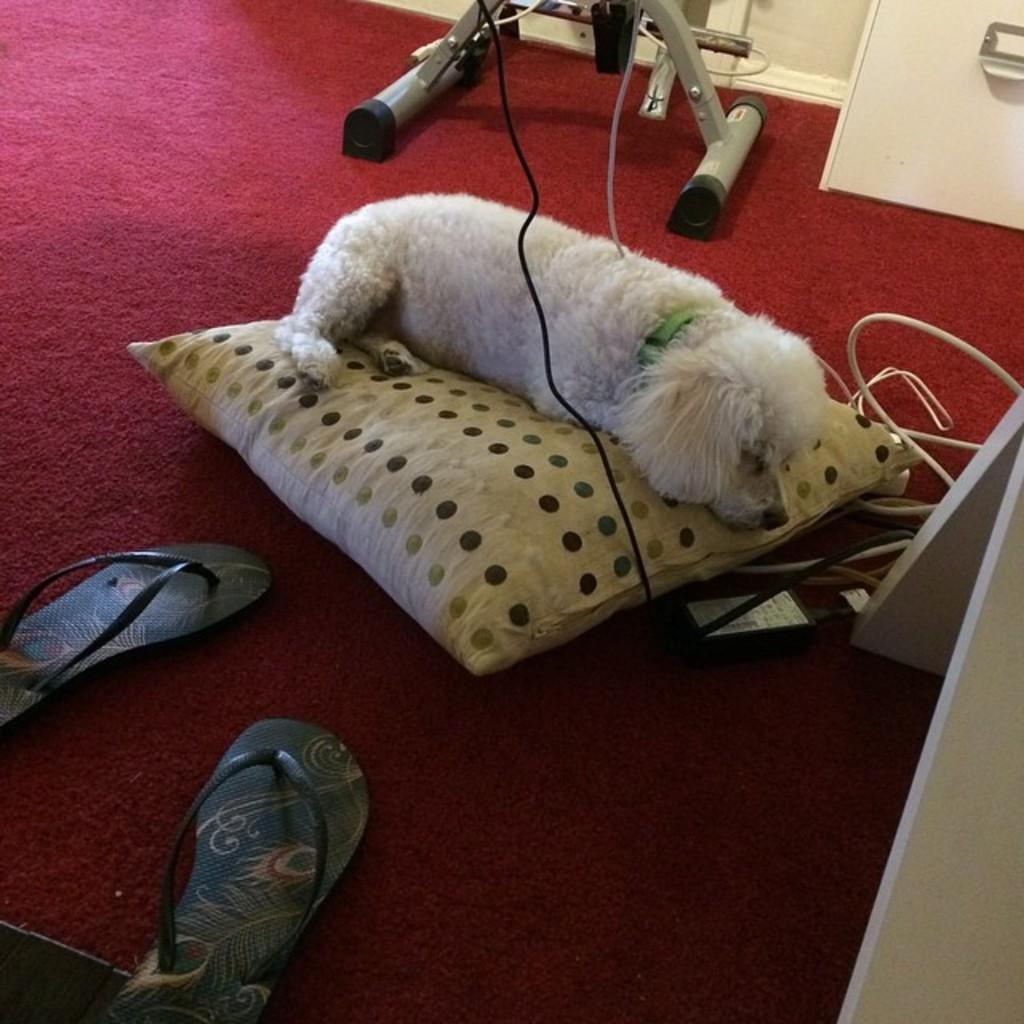How would you summarize this image in a sentence or two? This picture shows a dog lying on the pillow and we see pair of slippers on the red color carpet. The dog is white in color. 